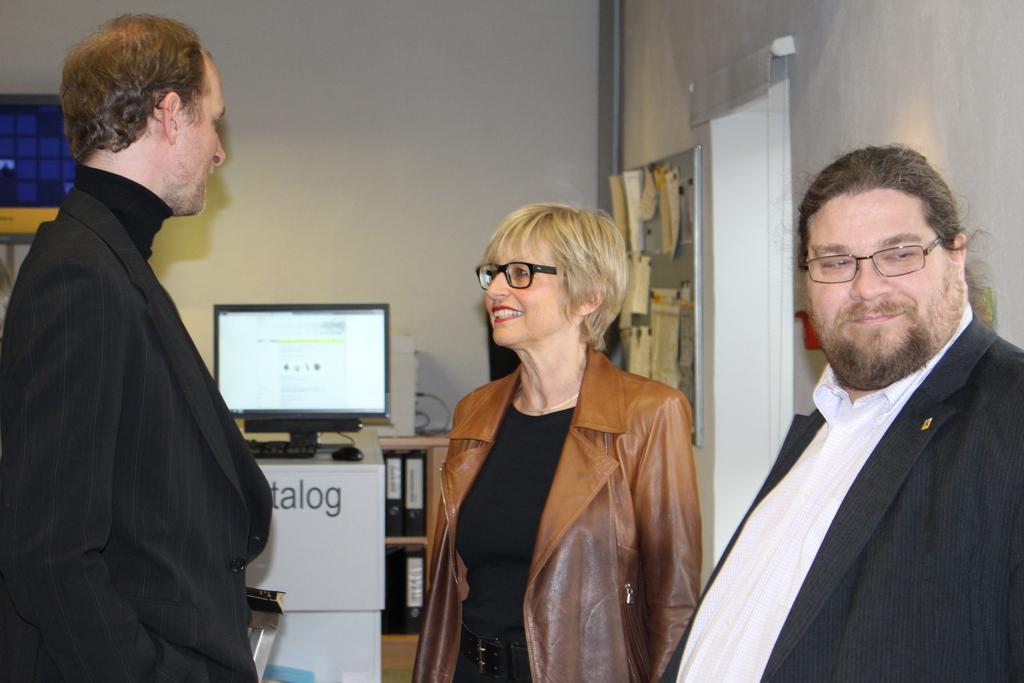Please provide a concise description of this image. In this picture I can see a man on the right side wearing black coat and spectacles. I can see a woman in the middle with smile wearing brown jacket and spectacles. I can see a man on the left side with a smile wearing black coat speaking towards women. 